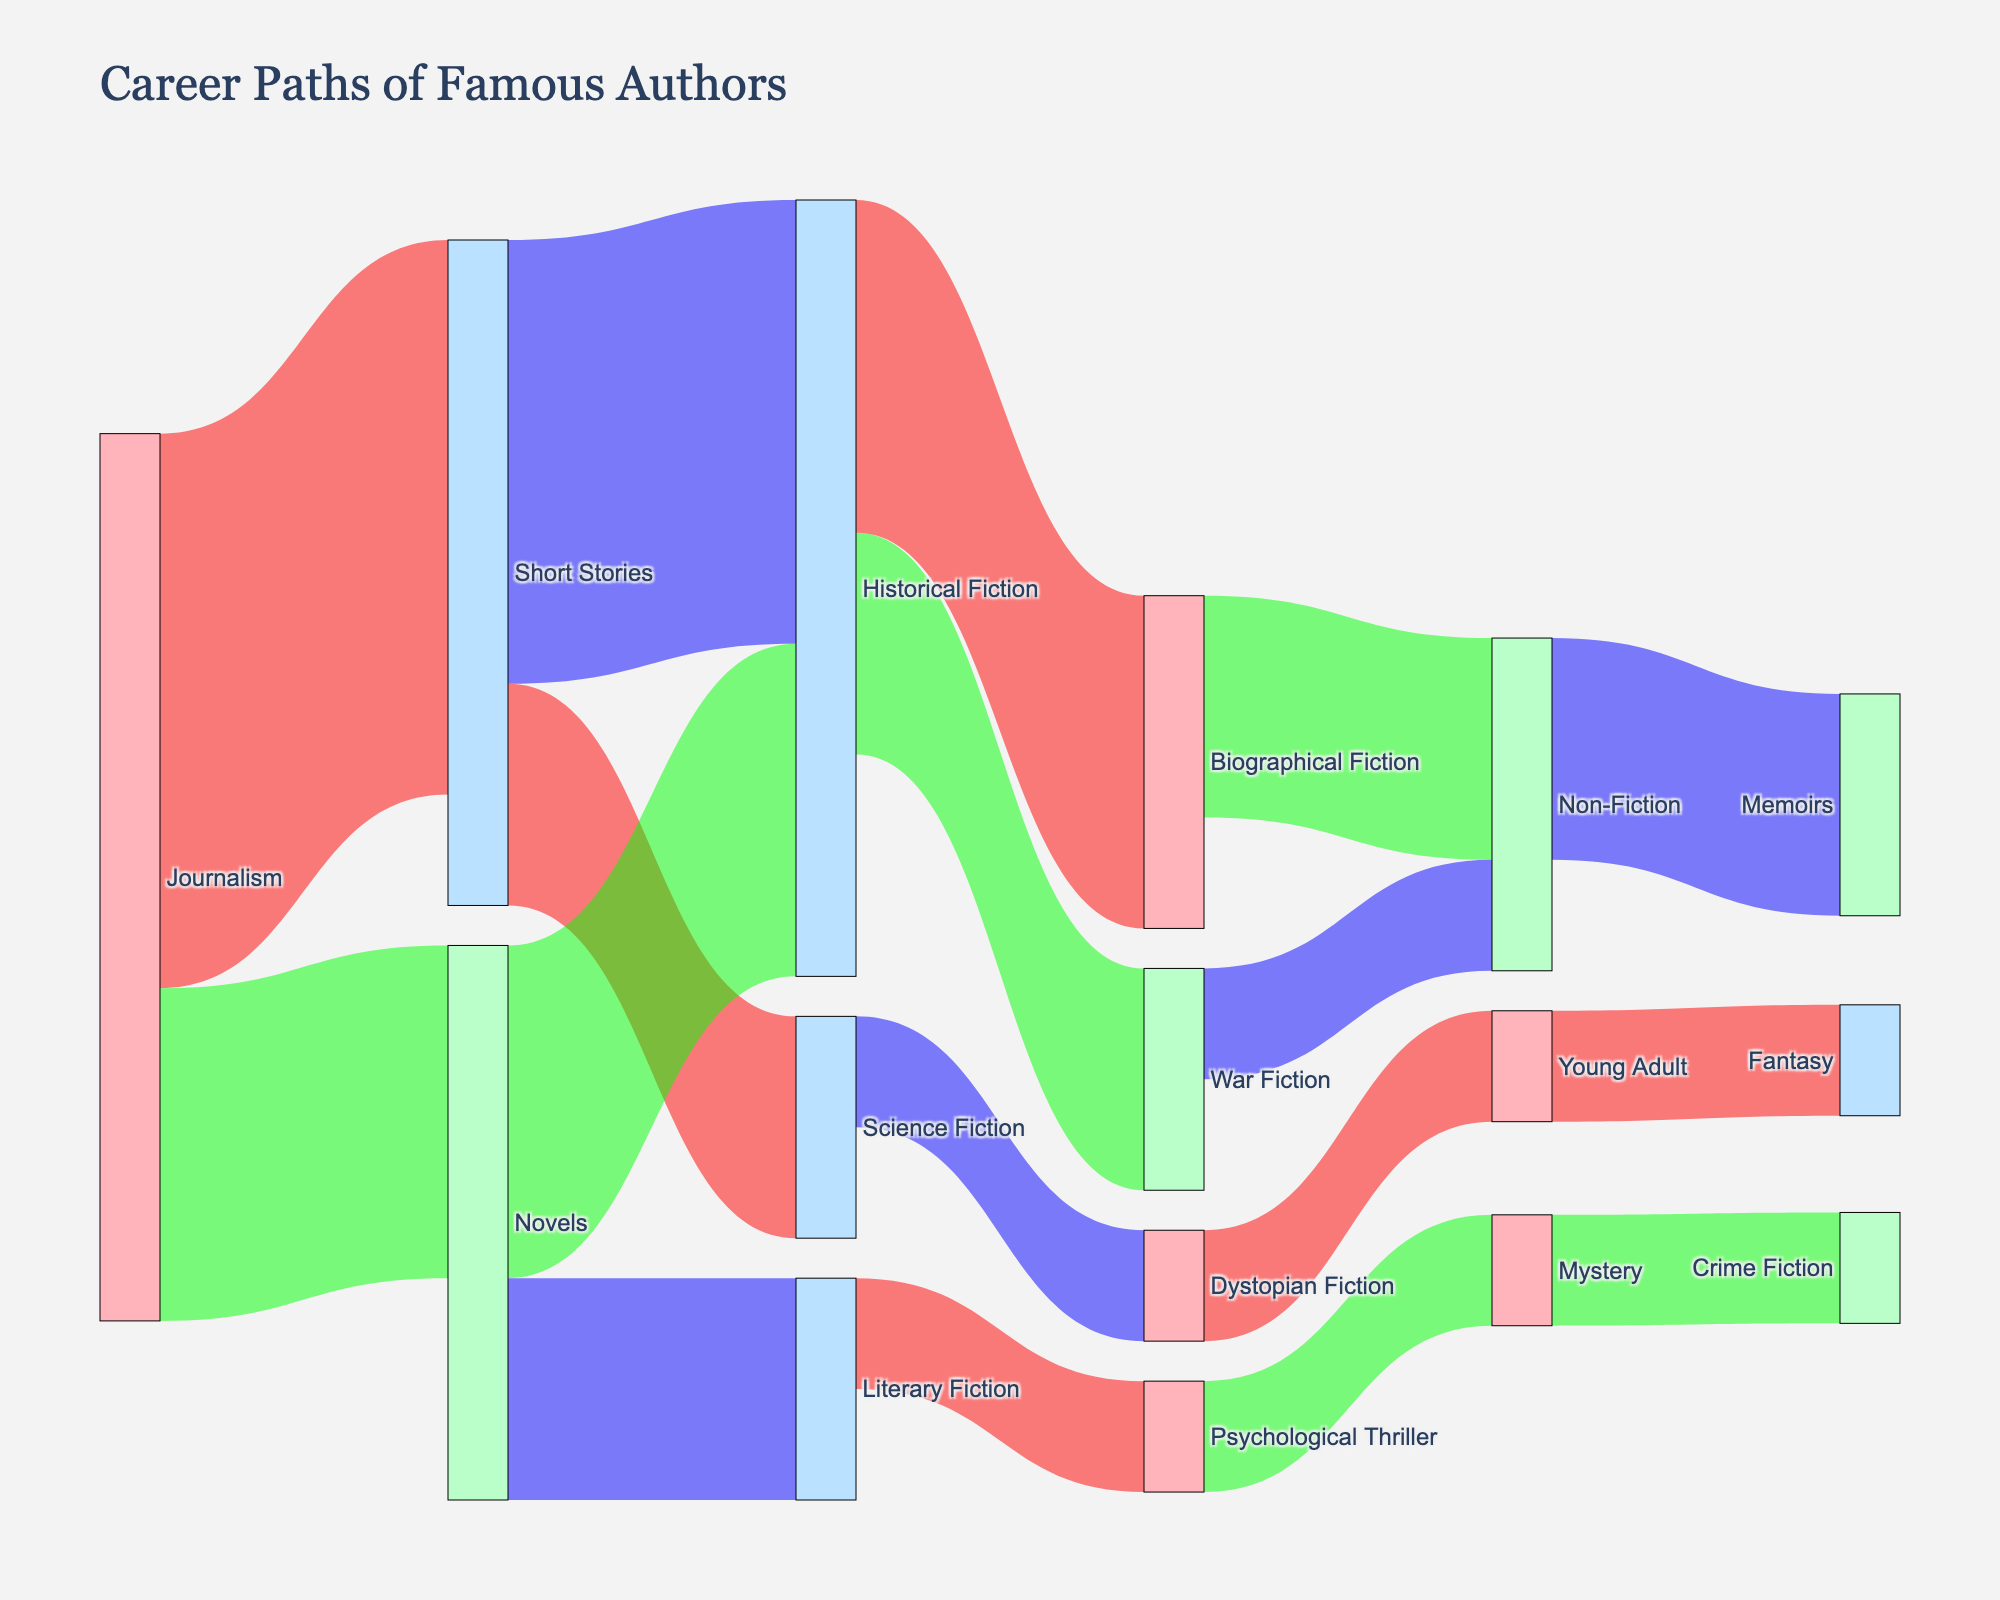How many authors transitioned from Journalism to writing novels? The figure shows the flow of authors from the Journalism node to the Novels node. The value attached to this link shows the number of authors.
Answer: 3 Which genre received the most transitions from Short Stories? By examining the links originating from Short Stories, we compare the values to see which genre received the highest value. Historical Fiction has a value of 4, while Science Fiction has a value of 2.
Answer: Historical Fiction How many total authors moved into Literary Fiction? To find this, sum the value of all transitions leading into Literary Fiction. According to the diagram, only the flow from Novels leads to Literary Fiction with a value of 2.
Answer: 2 What's the sum of authors reaching Non-Fiction from other genres? We need to add the values of all transitions leading to Non-Fiction. Biographical Fiction to Non-Fiction is 2 and War Fiction to Non-Fiction is 1, which sums to 3.
Answer: 3 Which genre is most connected to other genres (either as a source or target)? Count all the connections for each genre. Journalism has 2, Short Stories has 4, Novels has 3, Historical Fiction has 4, Science Fiction has 1, Literary Fiction has 2, Biographical Fiction has 1, War Fiction has 1, Dystopian Fiction has 1, Psychological Thriller has 1, Non-Fiction has 1, Young Adult has 1, Mystery has 1, and Fantasy has 1. Both Short Stories and Historical Fiction have the highest count of 4.
Answer: Short Stories, Historical Fiction How many authors transitioned from genres related to historical themes (e.g., Historical Fiction, Biographical Fiction, War Fiction) to other genres? This requires summing the values of transitions starting from Historical Fiction, Biographical Fiction, and War Fiction. Historical Fiction's transitions are 3 (to Biographical Fiction) + 2 (to War Fiction) = 5. Biographical Fiction has 2 (to Non-Fiction). War Fiction has 1 (to Non-Fiction). Total is 5 + 2 + 1 = 8.
Answer: 8 Which genre had the least transitions leading to other genres? Observing the diagram, we see that Young Adult, Fantasy, and Mystery each have only one outflow. Comparing values, each of these genres has only a single transition.
Answer: Young Adult, Fantasy, Mystery What percent of Short Stories authors moved to Science Fiction? We first find the total transitions from Short Stories: 4 (to Historical Fiction) + 2 (to Science Fiction) = 6. Then, we find the percentage for Science Fiction: (2/6) * 100 = 33.33%.
Answer: 33.33% From which genre did Fantasy receive its transition? By tracking the flow leading to Fantasy, we see only one transition coming from Young Adult.
Answer: Young Adult 